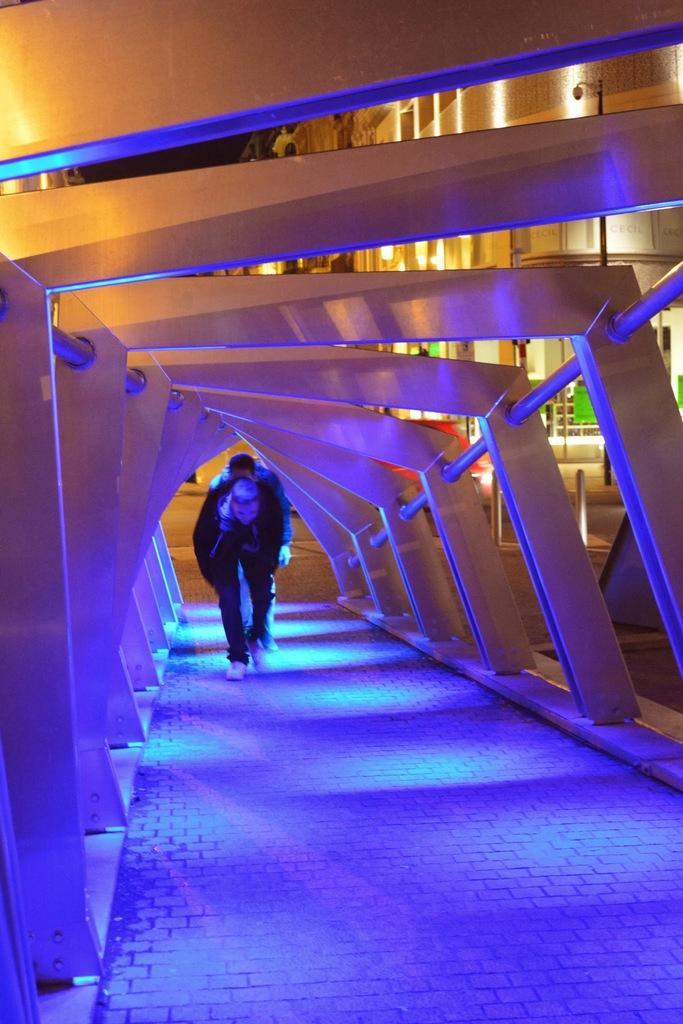Describe this image in one or two sentences. In this image there are two persons walking on the walkway , and in the background there are buildings , sky. 